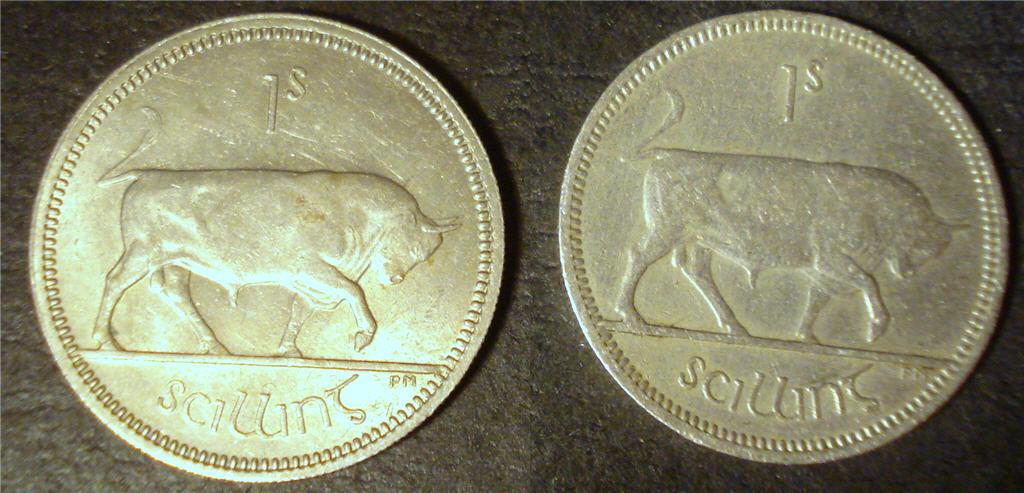<image>
Render a clear and concise summary of the photo. 2 silver coins side by side with the words scillint on them 